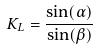<formula> <loc_0><loc_0><loc_500><loc_500>K _ { L } = \frac { \sin ( \alpha ) } { \sin ( \beta ) }</formula> 